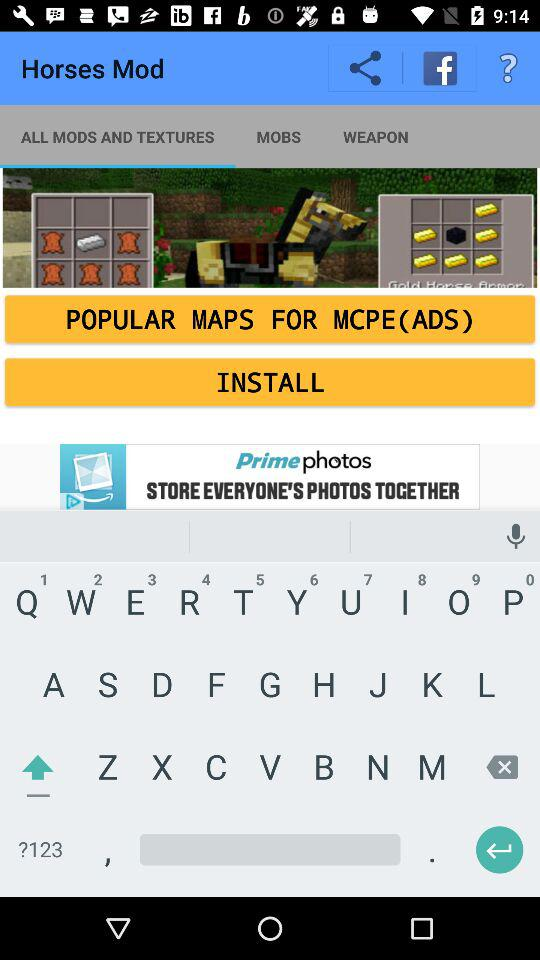What is the app title? The app title is "Horses Mod". 